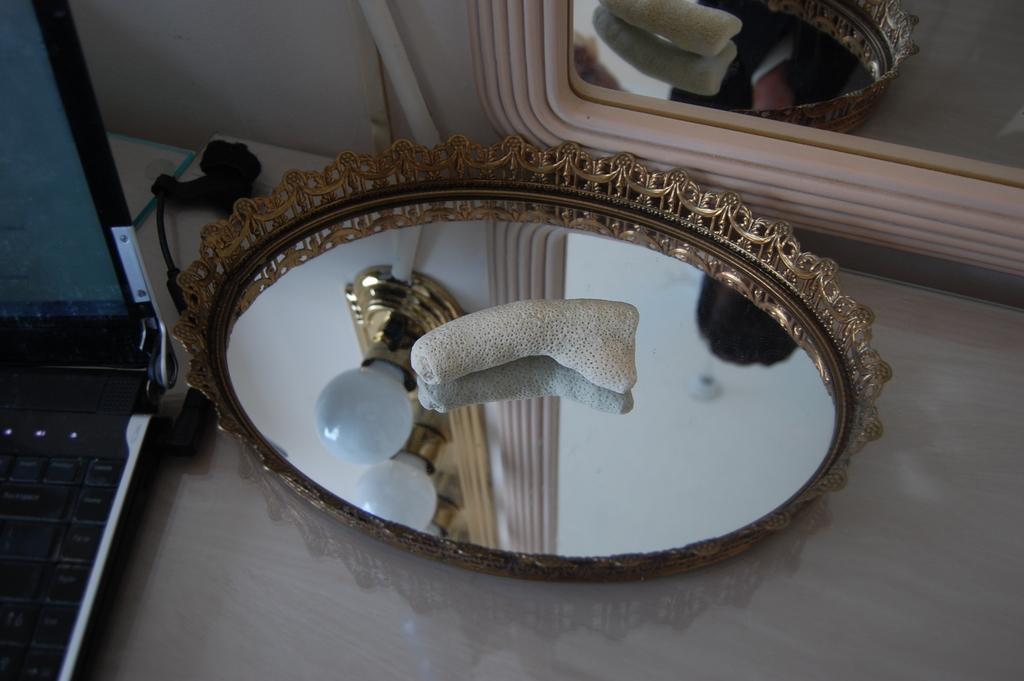What electronic device is visible on the left side of the image? There is a laptop on the left side of the image. What object is used for self-reflection or checking appearance in the image? There is a mirror in the image. What can be seen in the mirror's reflection? The reflection of a light is visible in the mirror. Can you see a river flowing in the image? There is no river present in the image. How does the sky look like in the image? The provided facts do not mention the sky, so we cannot determine its appearance from the image. 